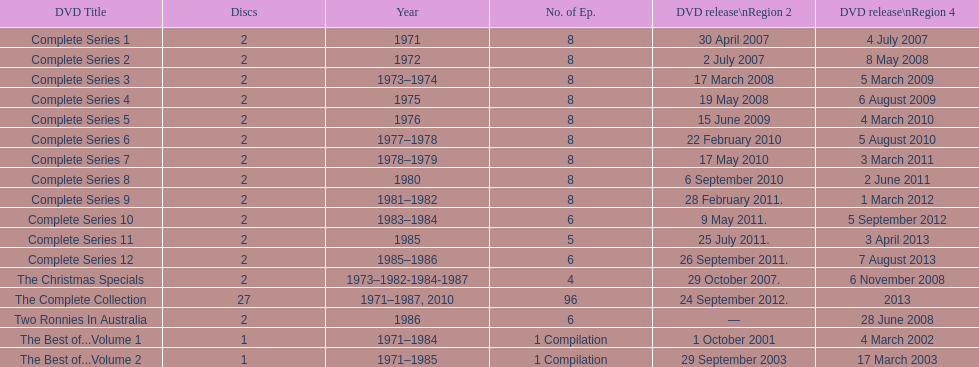How many series consisted of 8 episodes? 9. 